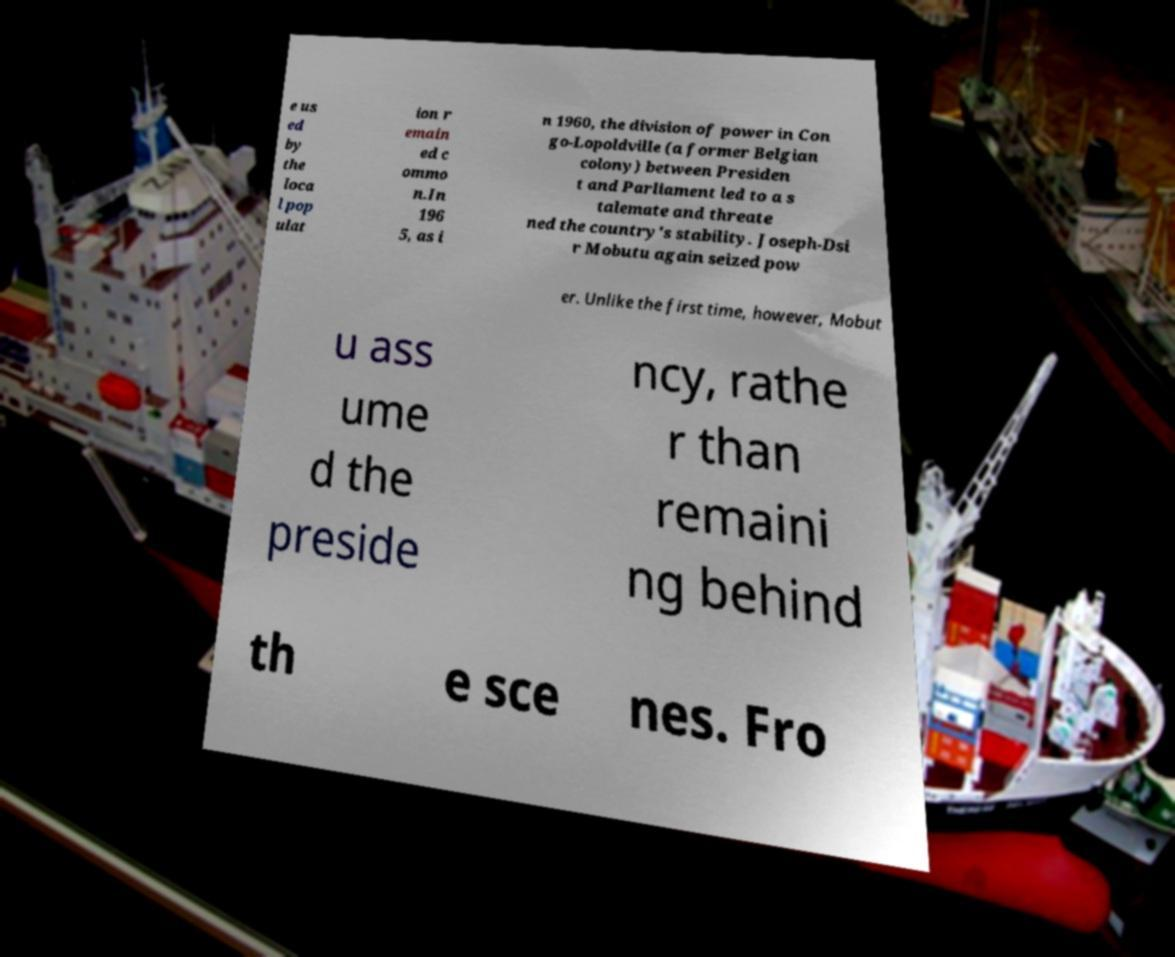I need the written content from this picture converted into text. Can you do that? e us ed by the loca l pop ulat ion r emain ed c ommo n.In 196 5, as i n 1960, the division of power in Con go-Lopoldville (a former Belgian colony) between Presiden t and Parliament led to a s talemate and threate ned the country's stability. Joseph-Dsi r Mobutu again seized pow er. Unlike the first time, however, Mobut u ass ume d the preside ncy, rathe r than remaini ng behind th e sce nes. Fro 